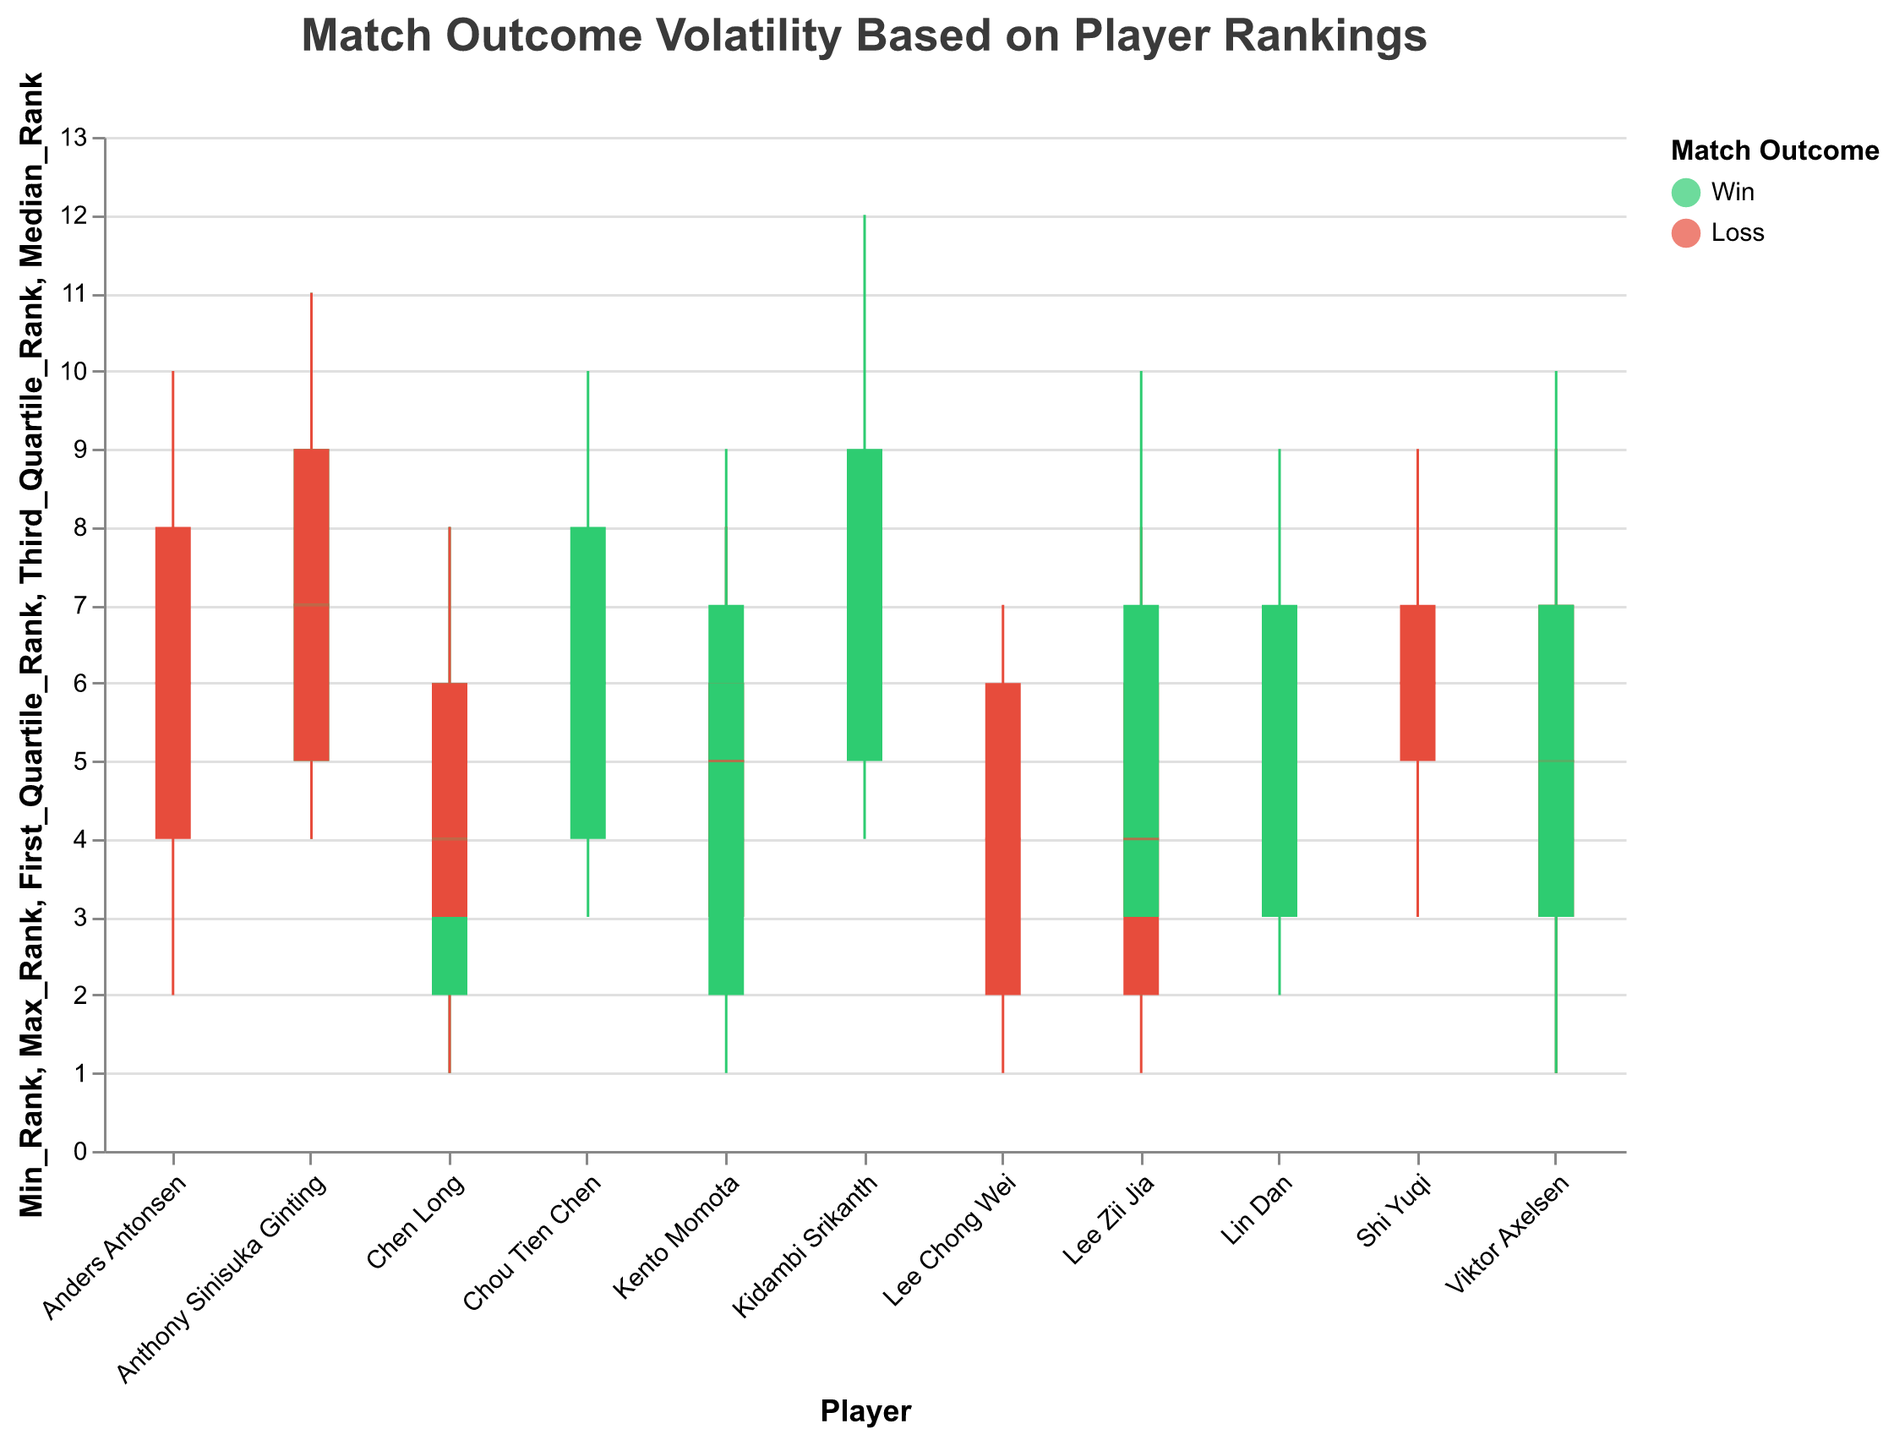What is the title of the plot? The title is typically located at the top of the plot and is the most straightforward to identify. In this case, it is written in a larger font for emphasis.
Answer: Match Outcome Volatility Based on Player Rankings Which player has the highest max rank in the Japan Open? By examining the max rank values within the "Japan Open" section, we find that Kidambi Srikanth has a max rank of 12, which is the highest for that tournament.
Answer: Kidambi Srikanth What is the median rank of Lee Zii Jia in the All England Open? Looking at Lee Zii Jia's median rank within the candlestick for the All England Open, we see it is marked at rank 4.
Answer: 4 Who won the Japanese Open with a first quartile rank less than 5? Kento Momota, Kidambi Srikanth, and Chou Tien Chen's quartile ranks are below 5 in the Japan Open. Checking the outcome, Kidambi Srikanth and Chou Tien Chen both won.
Answer: Kidambi Srikanth, Chou Tien Chen Was Viktor Axelsen’s performance in the Denmark Open better or worse compared to his performance in the All England Open based on the match outcome? Viktor Axelsen's match outcome in the All England Open is a win, while in the Denmark Open, it is a loss. So, his performance in the Denmark Open was worse.
Answer: Worse Compare the first quartile ranks of Anthony Sinisuka Ginting across different tournaments. Which tournament had the highest first quartile rank? Examine the first quartile ranks of Anthony Sinisuka Ginting in all his tournaments: Denmark Open (5), Indonesia Open (5). There is no difference between the highest values.
Answer: Denmark Open, Indonesia Open Which player had the smallest range of rank variability in the Malaysian Open? The range of variability is given by Max_Rank - Min_Rank. Comparing all players in the Malaysian Open: Lee Chong Wei (6), Lin Dan (7), Chen Long (7). Lee Chong Wei has the smallest range (7 - 1).
Answer: Lee Chong Wei Did any player have a better outcome in two different tournaments when their median rank was the same? Viktor Axelsen has a median rank of 5 in both Denmark Open (Loss) and China Open (Win). Hence, he had a better outcome in the China Open.
Answer: Viktor Axelsen Among the winners, which player had the widest interquartile range (IQR) in their rankings? The IQR is measured by Third_Quartile_Rank - First_Quartile_Rank. Calculate for each winner and compare: Kento Momota (All England Open: 4), Viktor Axelsen (All England Open: 4), Anthony Sinisuka Ginting (Denmark Open: 4), Kento Momota (Indonesia Open: 4), Kidambi Srikanth (Japan Open: 4), Chou Tien Chen (Japan Open: 4), Chen Long (China Open: 4). All have the same IQR.
Answer: All winning players have the same IQR of 4 